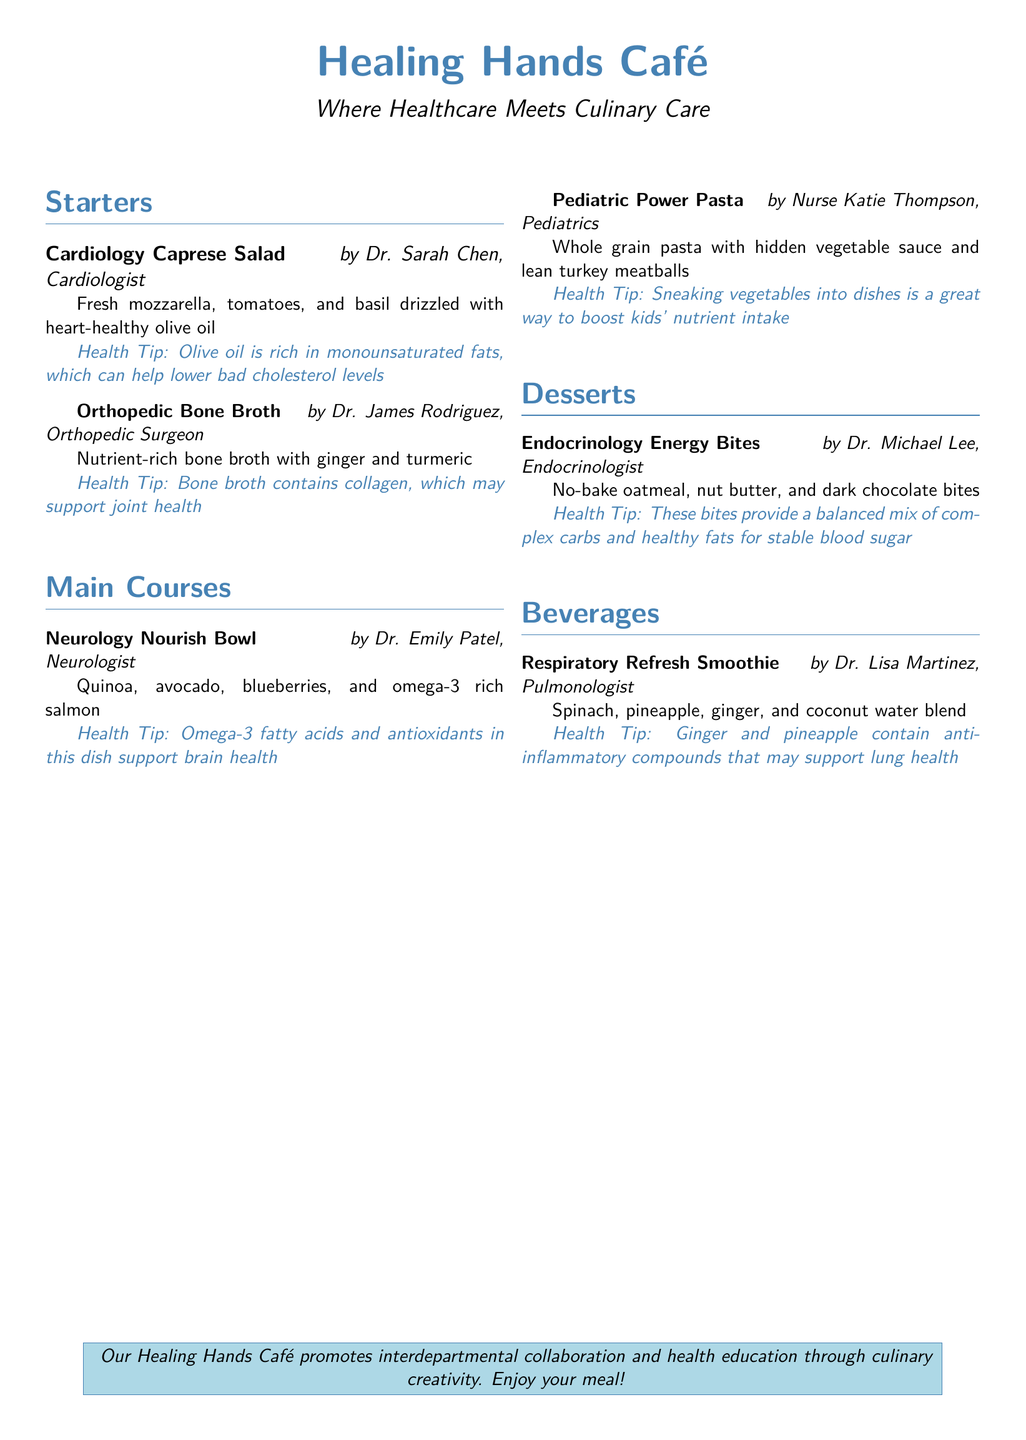What is the title of the café? The title of the café is prominently displayed at the top of the document.
Answer: Healing Hands Café Who created the "Cardiology Caprese Salad"? This information can be found next to the dish in the document.
Answer: Dr. Sarah Chen What ingredient is used in the "Neurology Nourish Bowl"? The ingredient is listed in the description of the dish in the document.
Answer: Quinoa What health tip is associated with the "Orthopedic Bone Broth"? The health tip is specified below the dish description.
Answer: Bone broth contains collagen, which may support joint health How many sections are in the menu? The sections are clearly labeled in the document, providing a count.
Answer: Four What is the main ingredient in the "Endocrinology Energy Bites"? The main ingredient can be identified from the dish description in the document.
Answer: Oatmeal Which beverage uses spinach as an ingredient? The beverage can be located within the beverage section of the document.
Answer: Respiratory Refresh Smoothie What is the central theme promoted by the café? This information can be found in the concluding section of the document.
Answer: Interdepartmental collaboration and health education 